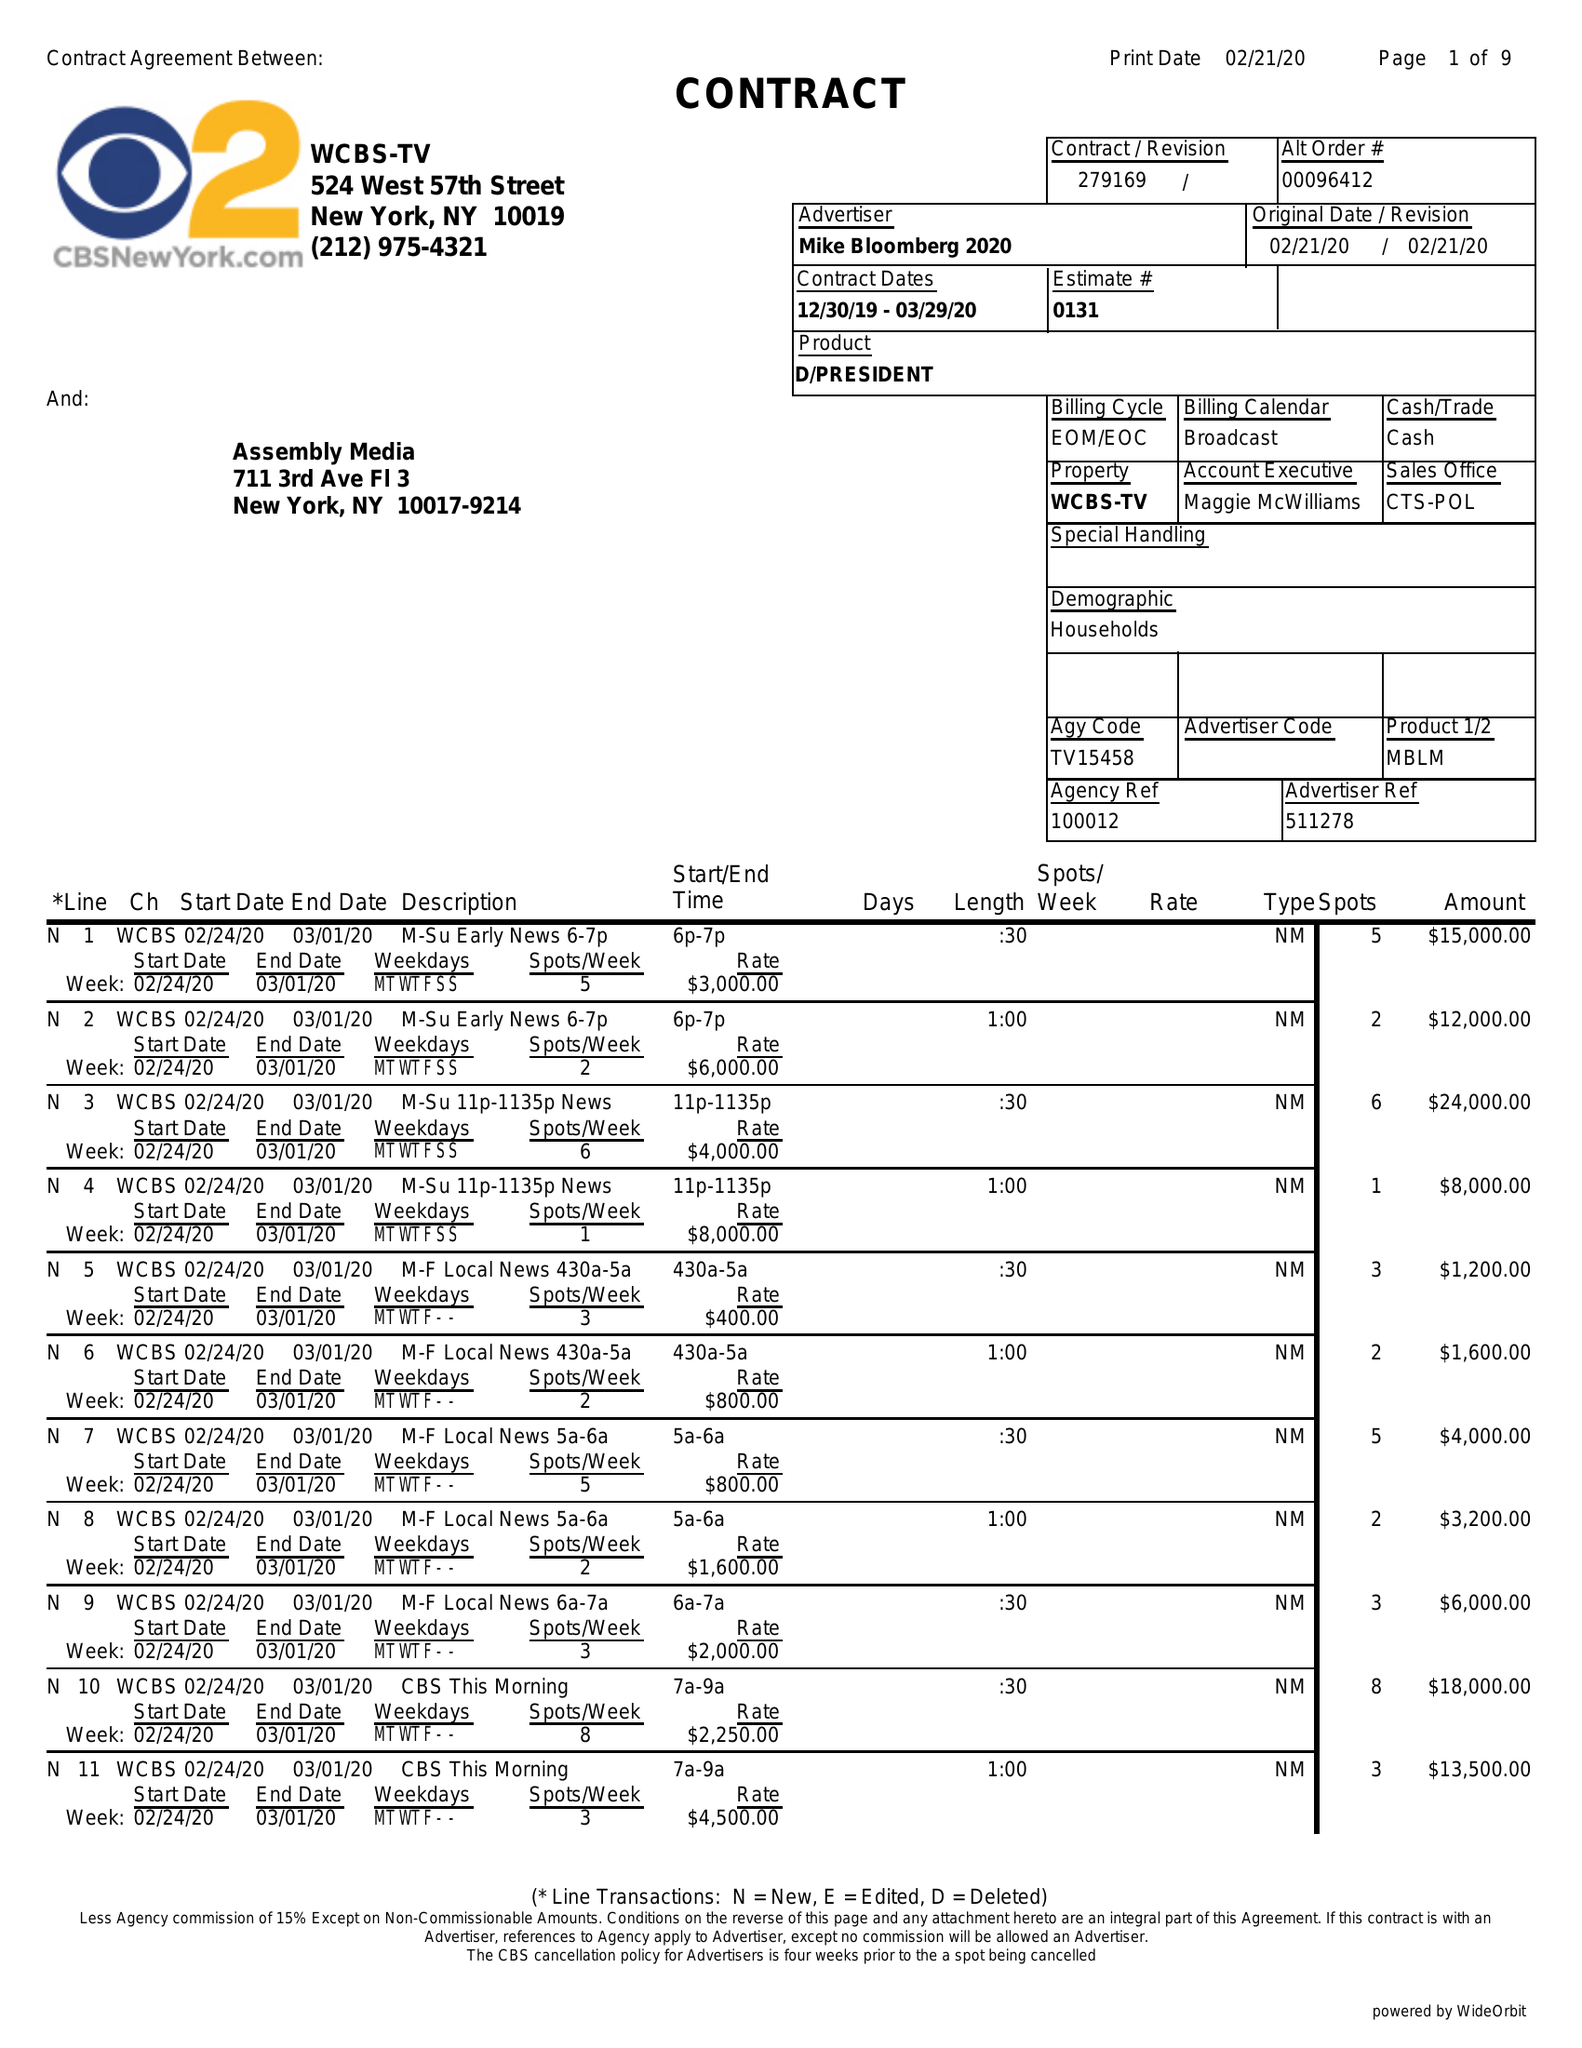What is the value for the advertiser?
Answer the question using a single word or phrase. MIKE BLOOMBERG 2020 